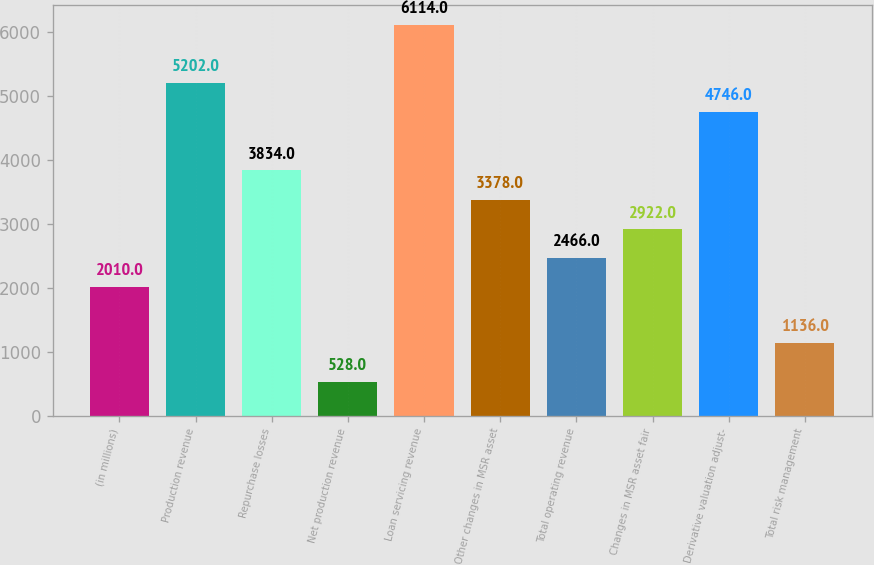Convert chart to OTSL. <chart><loc_0><loc_0><loc_500><loc_500><bar_chart><fcel>(in millions)<fcel>Production revenue<fcel>Repurchase losses<fcel>Net production revenue<fcel>Loan servicing revenue<fcel>Other changes in MSR asset<fcel>Total operating revenue<fcel>Changes in MSR asset fair<fcel>Derivative valuation adjust-<fcel>Total risk management<nl><fcel>2010<fcel>5202<fcel>3834<fcel>528<fcel>6114<fcel>3378<fcel>2466<fcel>2922<fcel>4746<fcel>1136<nl></chart> 